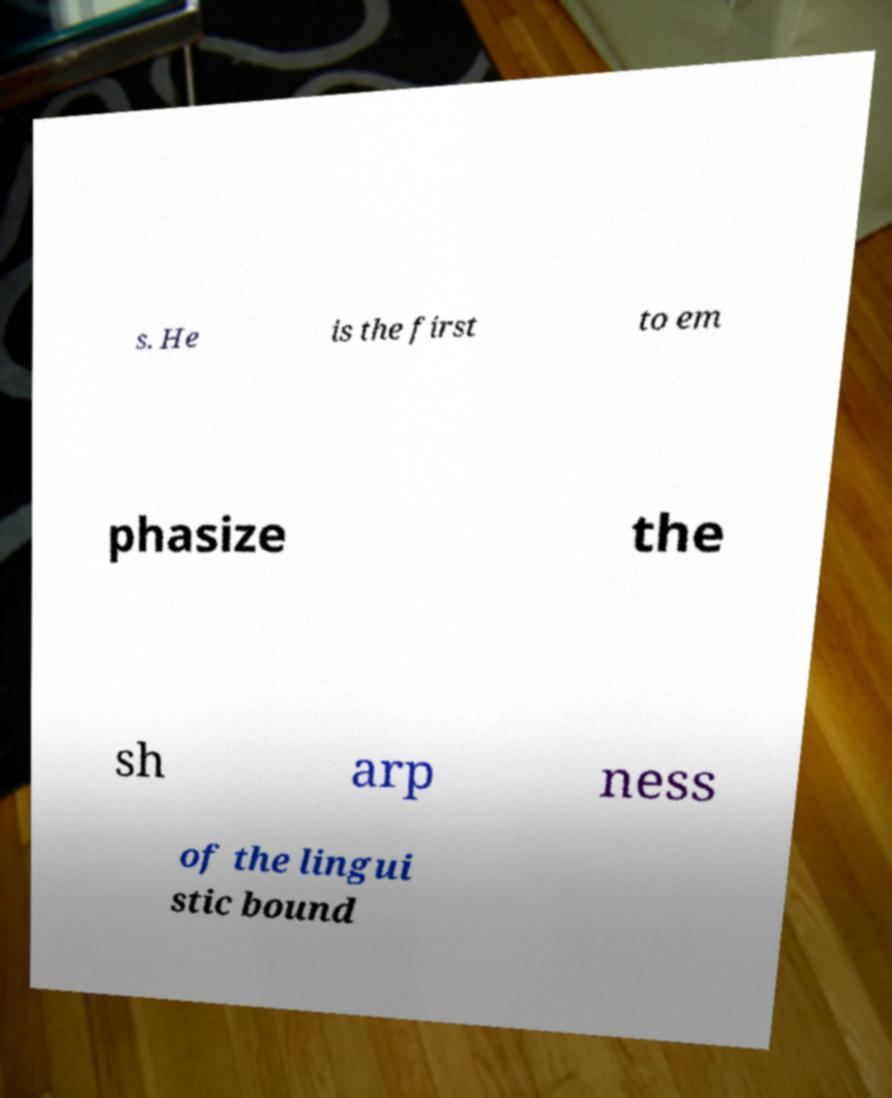There's text embedded in this image that I need extracted. Can you transcribe it verbatim? s. He is the first to em phasize the sh arp ness of the lingui stic bound 